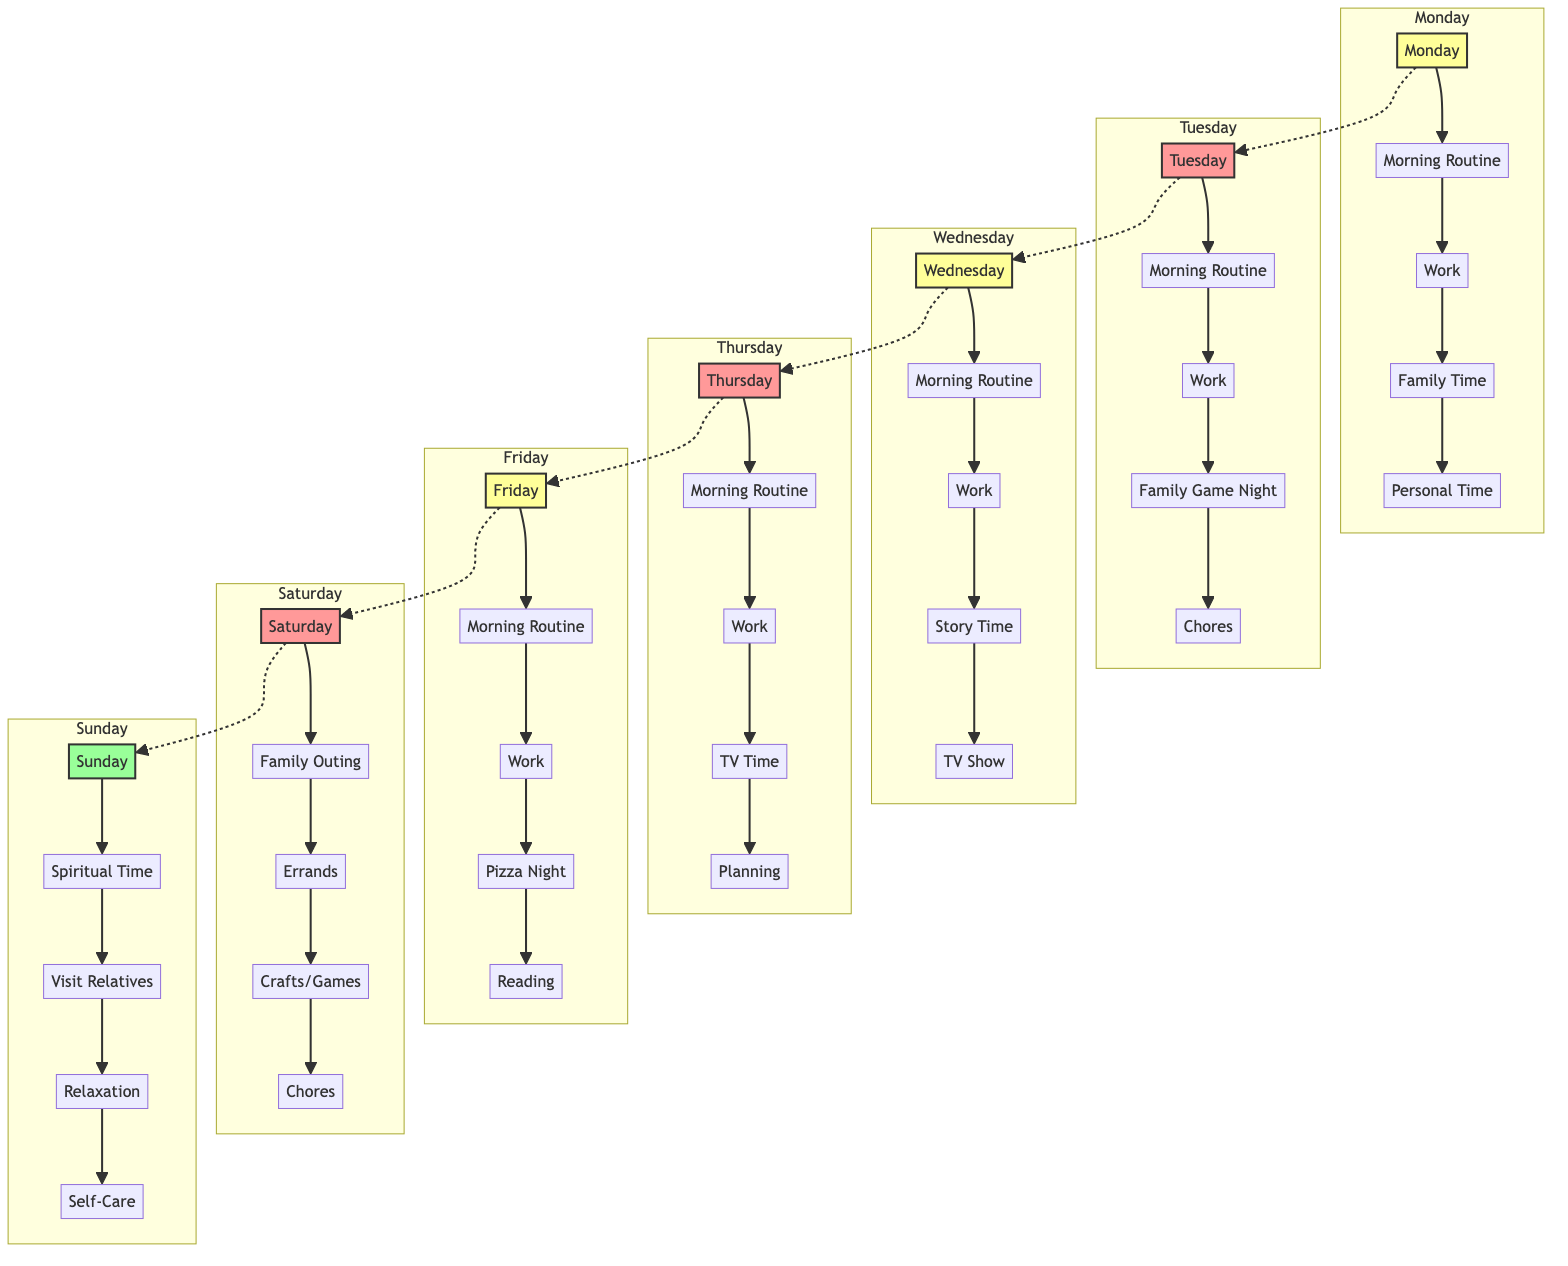What is the priority level of Thursday's activities? The diagram shows that Thursday's activities are categorized under the high priority class, as indicated by the coloring and classifications applied to that block.
Answer: High How many activities are scheduled on Saturday? By counting the activities listed in the Saturday block, there are a total of five activities from morning to bedtime, which are clearly enumerated in the diagram.
Answer: 5 What activity follows "Drop Kids at School" on Tuesday? In the Tuesday block, the diagram sequentially shows that "Work" follows "Drop Kids at School", which is explicitly outlined in the list of activities for that day.
Answer: Work Which day features a "Family Game Night"? The diagram identifies "Family Game Night" specifically under Tuesday's activities, illustrating the unique character of that day compared to others throughout the week.
Answer: Tuesday What is the last activity on Sunday? The diagram clearly describes the Sunday schedule, listing "Go to Bed" as the final activity, thus showing the culmination of the day's routine before sleep.
Answer: Go to Bed Which activity is highlighted as "Pizza Night"? The diagram shows "Pizza Night" as a special event marked on Friday, distinctly outlined within the sequence of activities and contributing to the uniqueness of that day's routine.
Answer: Friday Pizza Night On which day is "Relaxation and TV Time" scheduled? The diagram includes "Relaxation and TV Time" in the Thursday activities block, demonstrating the planned time for rest and leisure on that particular day.
Answer: Thursday How does Monday's routine conclude? The diagram illustrates that Monday's routine ends with "Go to Bed", thereby highlighting the structure and routine end for the day.
Answer: Go to Bed What type of diagram is shown? The diagram displays a block diagram type, evident from the structured blocks representing different days and activities categorized by priority levels.
Answer: Block Diagram 